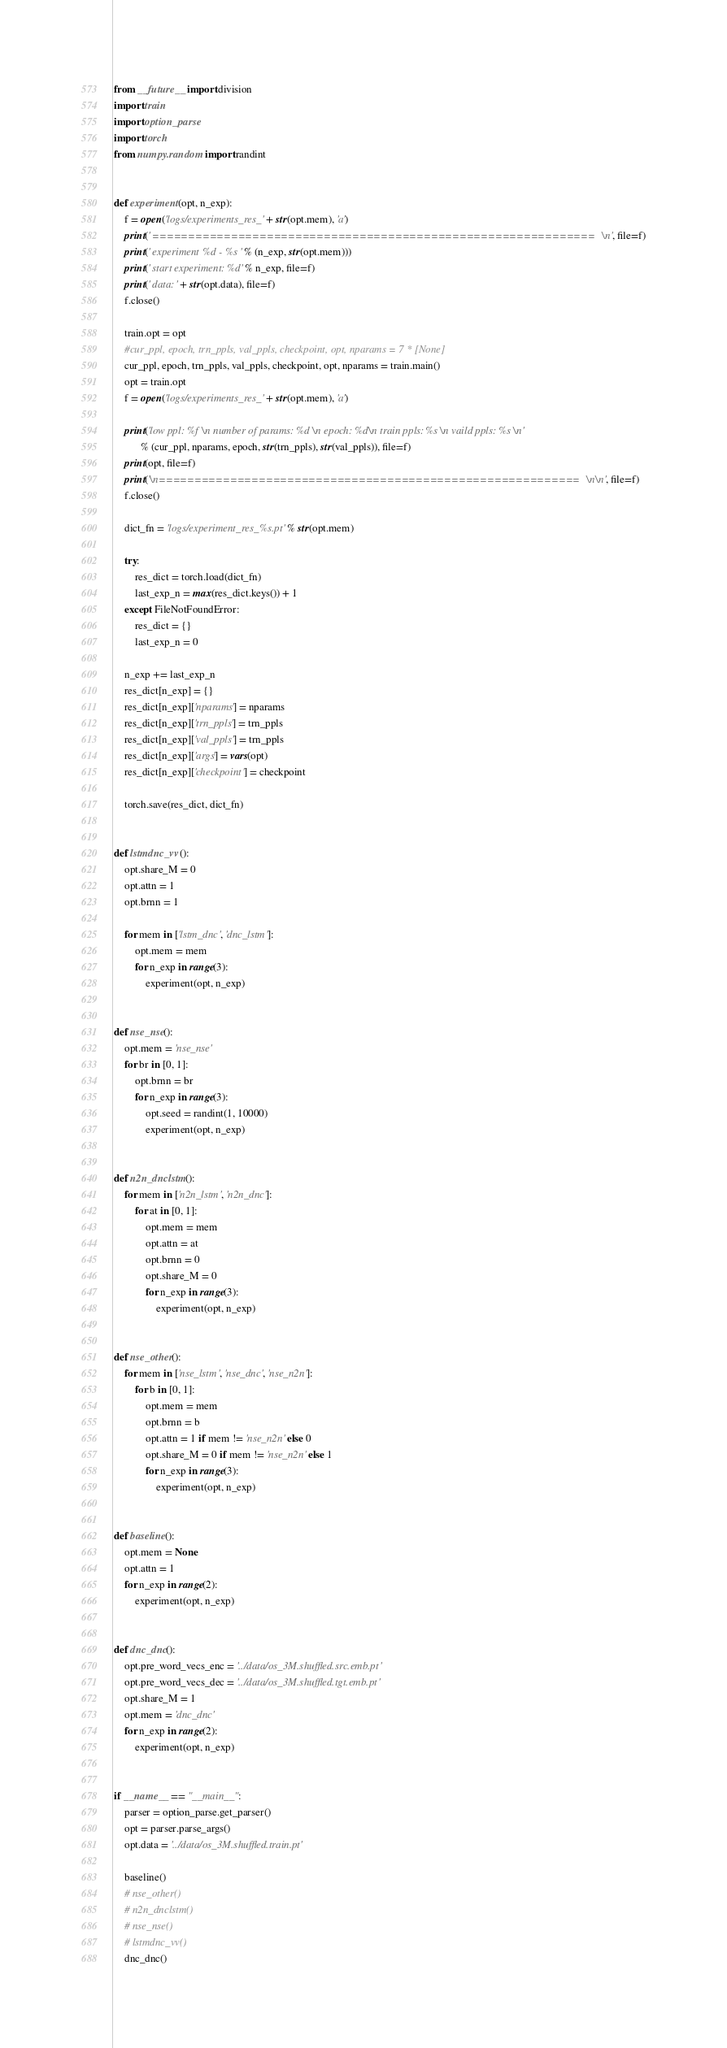Convert code to text. <code><loc_0><loc_0><loc_500><loc_500><_Python_>from __future__ import division
import train
import option_parse
import torch
from numpy.random import randint


def experiment(opt, n_exp):
    f = open('logs/experiments_res_' + str(opt.mem), 'a')
    print(' ==============================================================\n', file=f)
    print(' experiment %d - %s ' % (n_exp, str(opt.mem)))
    print(' start experiment: %d' % n_exp, file=f)
    print(' data: ' + str(opt.data), file=f)
    f.close()

    train.opt = opt
    #cur_ppl, epoch, trn_ppls, val_ppls, checkpoint, opt, nparams = 7 * [None]
    cur_ppl, epoch, trn_ppls, val_ppls, checkpoint, opt, nparams = train.main()
    opt = train.opt
    f = open('logs/experiments_res_' + str(opt.mem), 'a')

    print('low ppl: %f \n number of params: %d \n epoch: %d\n train ppls: %s \n vaild ppls: %s \n'
          % (cur_ppl, nparams, epoch, str(trn_ppls), str(val_ppls)), file=f)
    print(opt, file=f)
    print('\n===========================================================\n\n', file=f)
    f.close()

    dict_fn = 'logs/experiment_res_%s.pt' % str(opt.mem)

    try:
        res_dict = torch.load(dict_fn)
        last_exp_n = max(res_dict.keys()) + 1
    except FileNotFoundError:
        res_dict = {}
        last_exp_n = 0

    n_exp += last_exp_n
    res_dict[n_exp] = {}
    res_dict[n_exp]['nparams'] = nparams
    res_dict[n_exp]['trn_ppls'] = trn_ppls
    res_dict[n_exp]['val_ppls'] = trn_ppls
    res_dict[n_exp]['args'] = vars(opt)
    res_dict[n_exp]['checkpoint'] = checkpoint

    torch.save(res_dict, dict_fn)


def lstmdnc_vv():
    opt.share_M = 0
    opt.attn = 1
    opt.brnn = 1

    for mem in ['lstm_dnc', 'dnc_lstm']:
        opt.mem = mem
        for n_exp in range(3):
            experiment(opt, n_exp)


def nse_nse():
    opt.mem = 'nse_nse'
    for br in [0, 1]:
        opt.brnn = br
        for n_exp in range(3):
            opt.seed = randint(1, 10000)
            experiment(opt, n_exp)


def n2n_dnclstm():
    for mem in ['n2n_lstm', 'n2n_dnc']:
        for at in [0, 1]:
            opt.mem = mem
            opt.attn = at
            opt.brnn = 0
            opt.share_M = 0
            for n_exp in range(3):
                experiment(opt, n_exp)


def nse_other():
    for mem in ['nse_lstm', 'nse_dnc', 'nse_n2n']:
        for b in [0, 1]:
            opt.mem = mem
            opt.brnn = b
            opt.attn = 1 if mem != 'nse_n2n' else 0
            opt.share_M = 0 if mem != 'nse_n2n' else 1
            for n_exp in range(3):
                experiment(opt, n_exp)


def baseline():
    opt.mem = None
    opt.attn = 1
    for n_exp in range(2):
        experiment(opt, n_exp)


def dnc_dnc():
    opt.pre_word_vecs_enc = '../data/os_3M.shuffled.src.emb.pt'
    opt.pre_word_vecs_dec = '../data/os_3M.shuffled.tgt.emb.pt'
    opt.share_M = 1
    opt.mem = 'dnc_dnc'
    for n_exp in range(2):
        experiment(opt, n_exp)


if __name__ == "__main__":
    parser = option_parse.get_parser()
    opt = parser.parse_args()
    opt.data = '../data/os_3M.shuffled.train.pt'

    baseline()
    # nse_other()
    # n2n_dnclstm()
    # nse_nse()
    # lstmdnc_vv()
    dnc_dnc()
</code> 